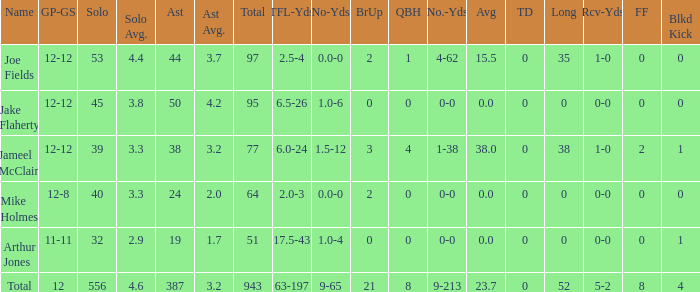What is the total brup for the team? 21.0. 